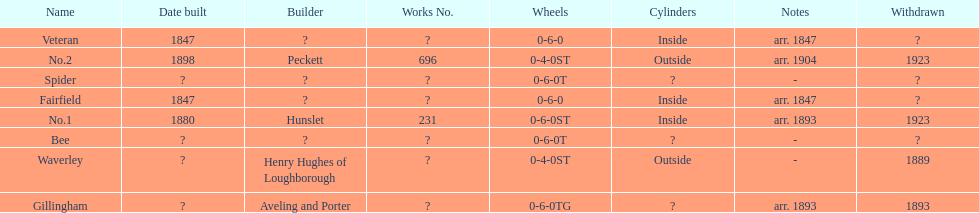How long after fairfield was no. 1 built? 33 years. 